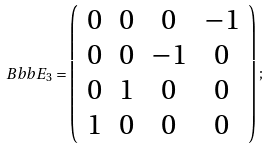Convert formula to latex. <formula><loc_0><loc_0><loc_500><loc_500>\ B b b { E } _ { 3 } = \left ( \begin{array} { c c c c } 0 & 0 & 0 & - 1 \\ 0 & 0 & - 1 & 0 \\ 0 & 1 & 0 & 0 \\ 1 & 0 & 0 & 0 \end{array} \right ) ;</formula> 